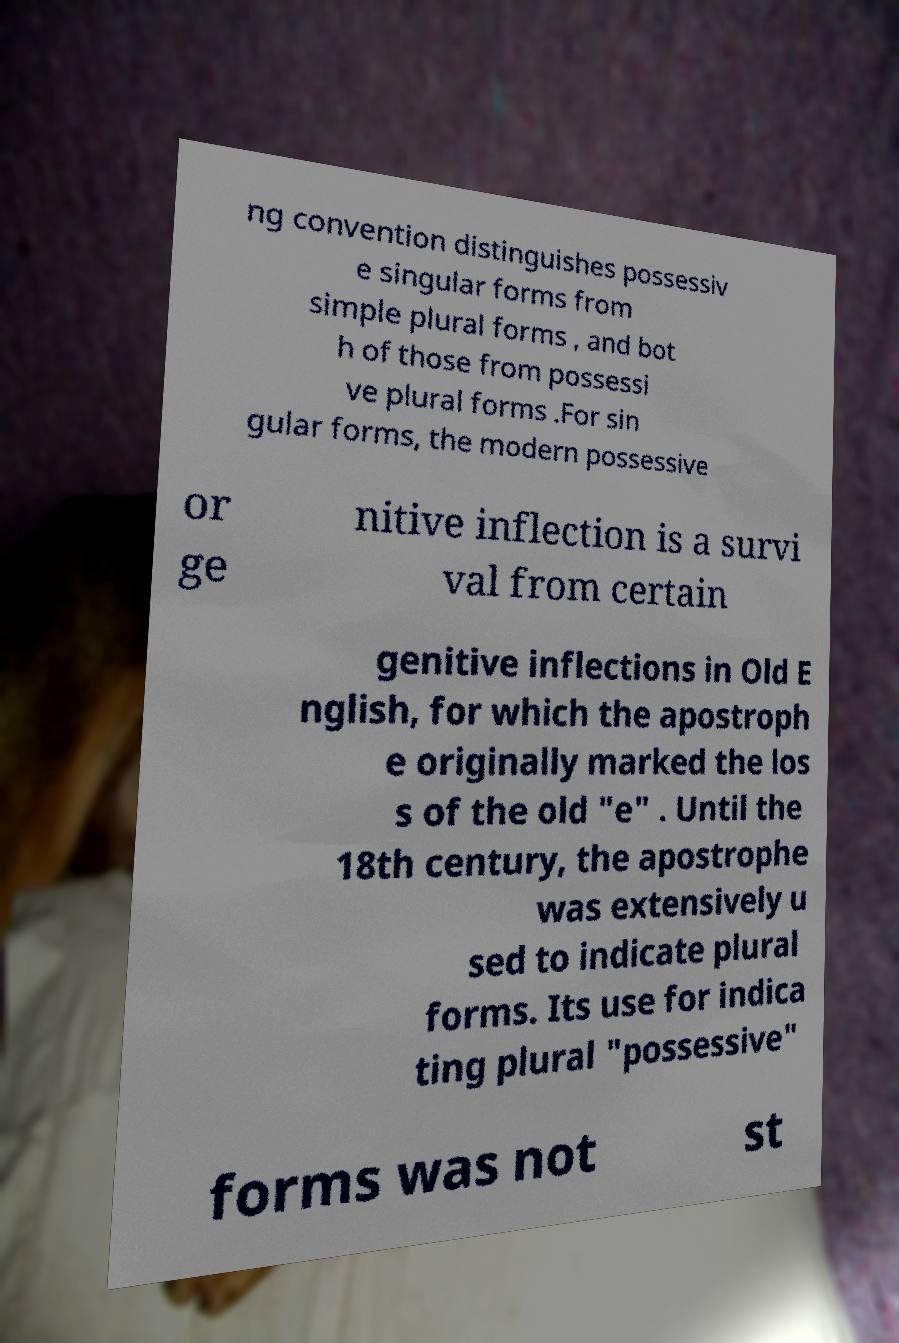For documentation purposes, I need the text within this image transcribed. Could you provide that? ng convention distinguishes possessiv e singular forms from simple plural forms , and bot h of those from possessi ve plural forms .For sin gular forms, the modern possessive or ge nitive inflection is a survi val from certain genitive inflections in Old E nglish, for which the apostroph e originally marked the los s of the old "e" . Until the 18th century, the apostrophe was extensively u sed to indicate plural forms. Its use for indica ting plural "possessive" forms was not st 